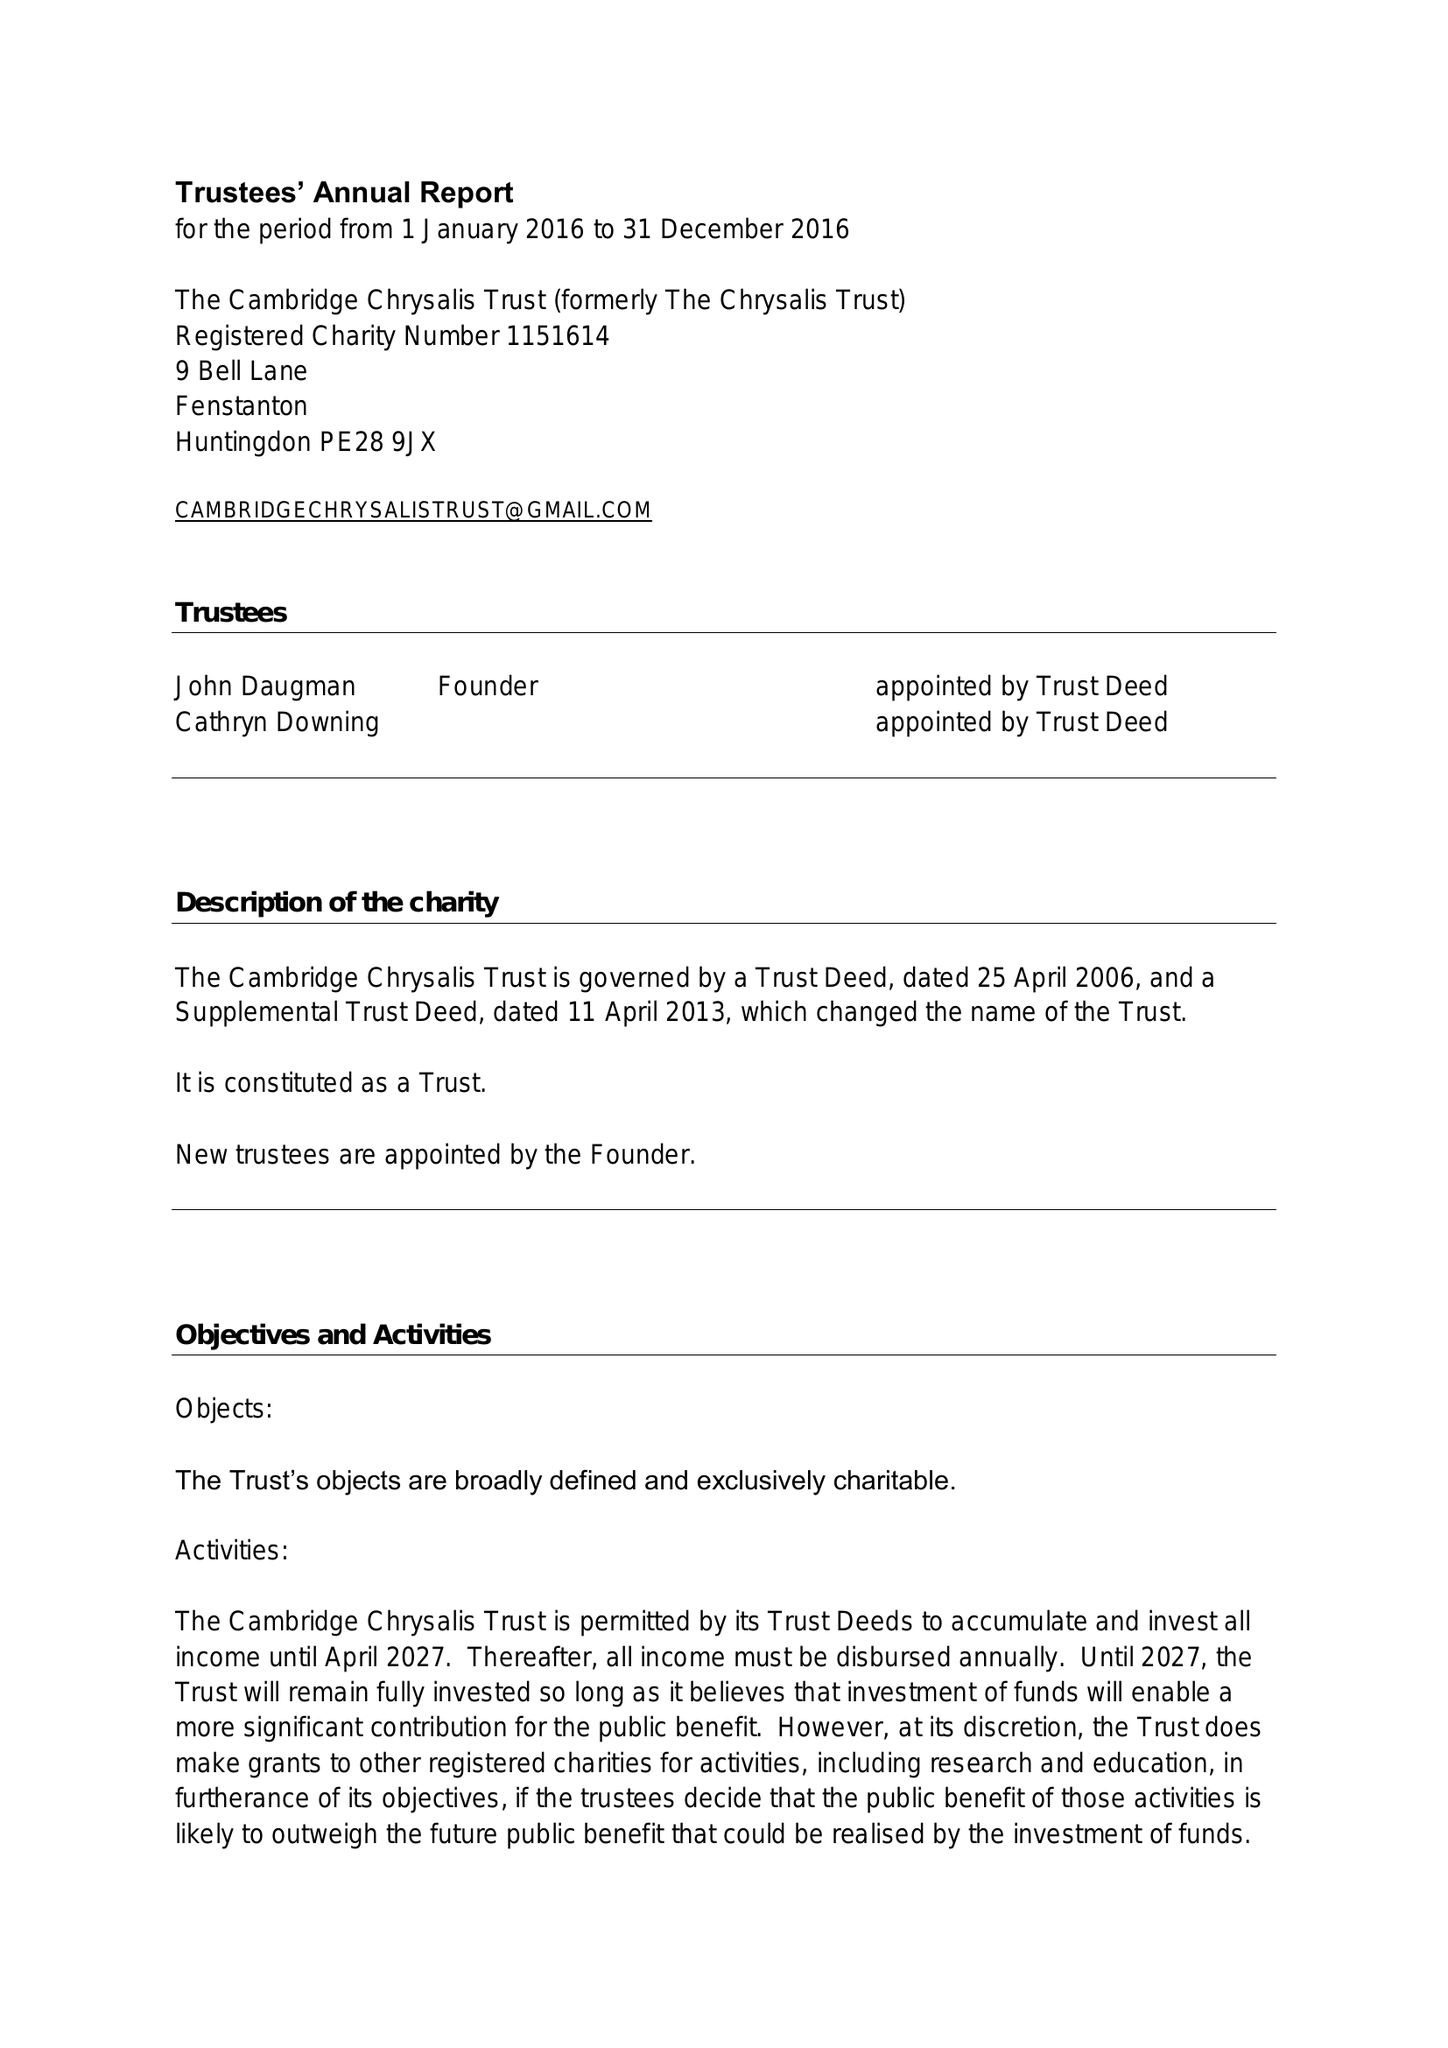What is the value for the address__post_town?
Answer the question using a single word or phrase. HUNTINGDON 